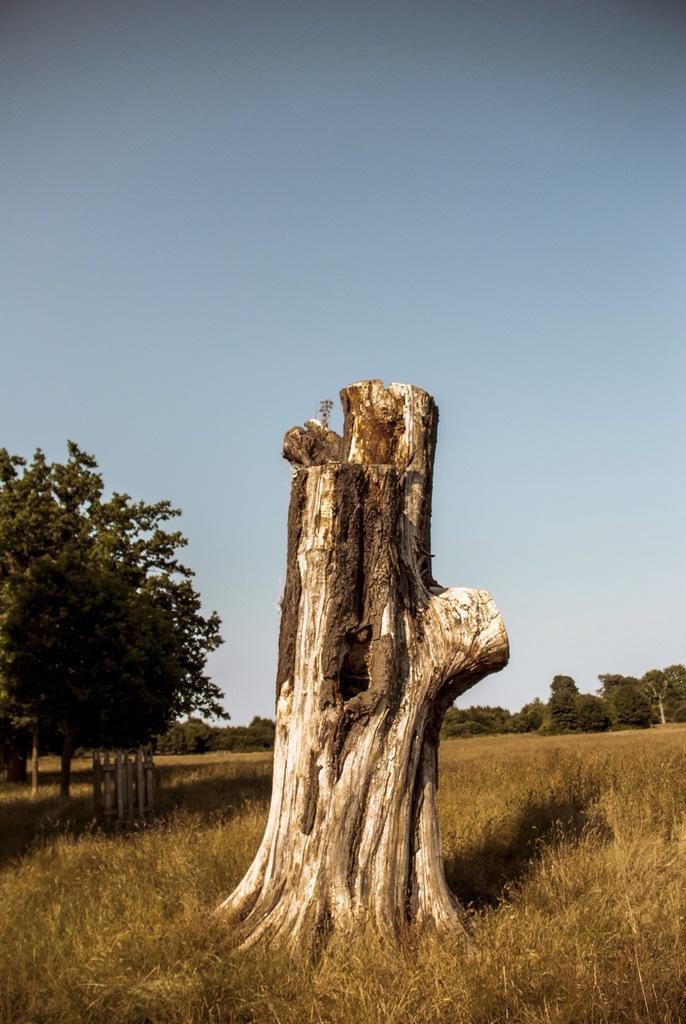In one or two sentences, can you explain what this image depicts? This picture might be taken from outside of the city. In this image, in the middle, we can see a wooden trunk. On the right side, we can see some trees and plants. On the left side, we can also see some trees and plants. On the top, we can see a sky, at the bottom there is a grass. 